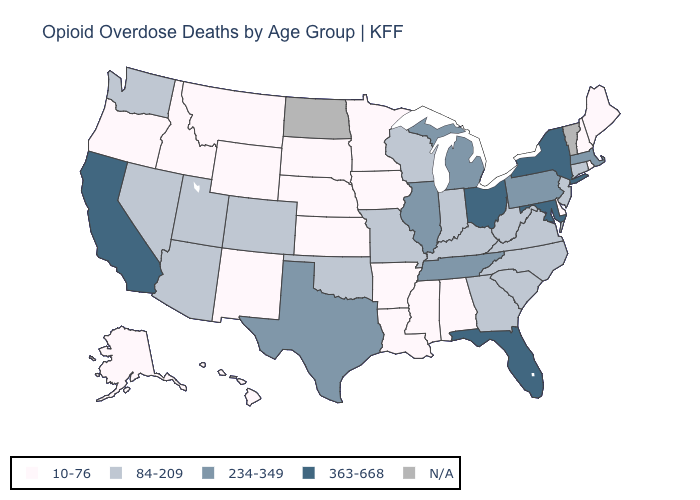Name the states that have a value in the range 234-349?
Be succinct. Illinois, Massachusetts, Michigan, Pennsylvania, Tennessee, Texas. What is the value of North Carolina?
Be succinct. 84-209. What is the value of Tennessee?
Write a very short answer. 234-349. What is the value of Georgia?
Concise answer only. 84-209. Does Missouri have the lowest value in the MidWest?
Quick response, please. No. How many symbols are there in the legend?
Keep it brief. 5. Does Ohio have the highest value in the USA?
Concise answer only. Yes. What is the highest value in the MidWest ?
Write a very short answer. 363-668. Name the states that have a value in the range 84-209?
Quick response, please. Arizona, Colorado, Connecticut, Georgia, Indiana, Kentucky, Missouri, Nevada, New Jersey, North Carolina, Oklahoma, South Carolina, Utah, Virginia, Washington, West Virginia, Wisconsin. What is the value of Iowa?
Be succinct. 10-76. Does Minnesota have the highest value in the MidWest?
Write a very short answer. No. Name the states that have a value in the range 234-349?
Write a very short answer. Illinois, Massachusetts, Michigan, Pennsylvania, Tennessee, Texas. What is the lowest value in the West?
Give a very brief answer. 10-76. Name the states that have a value in the range 234-349?
Short answer required. Illinois, Massachusetts, Michigan, Pennsylvania, Tennessee, Texas. 